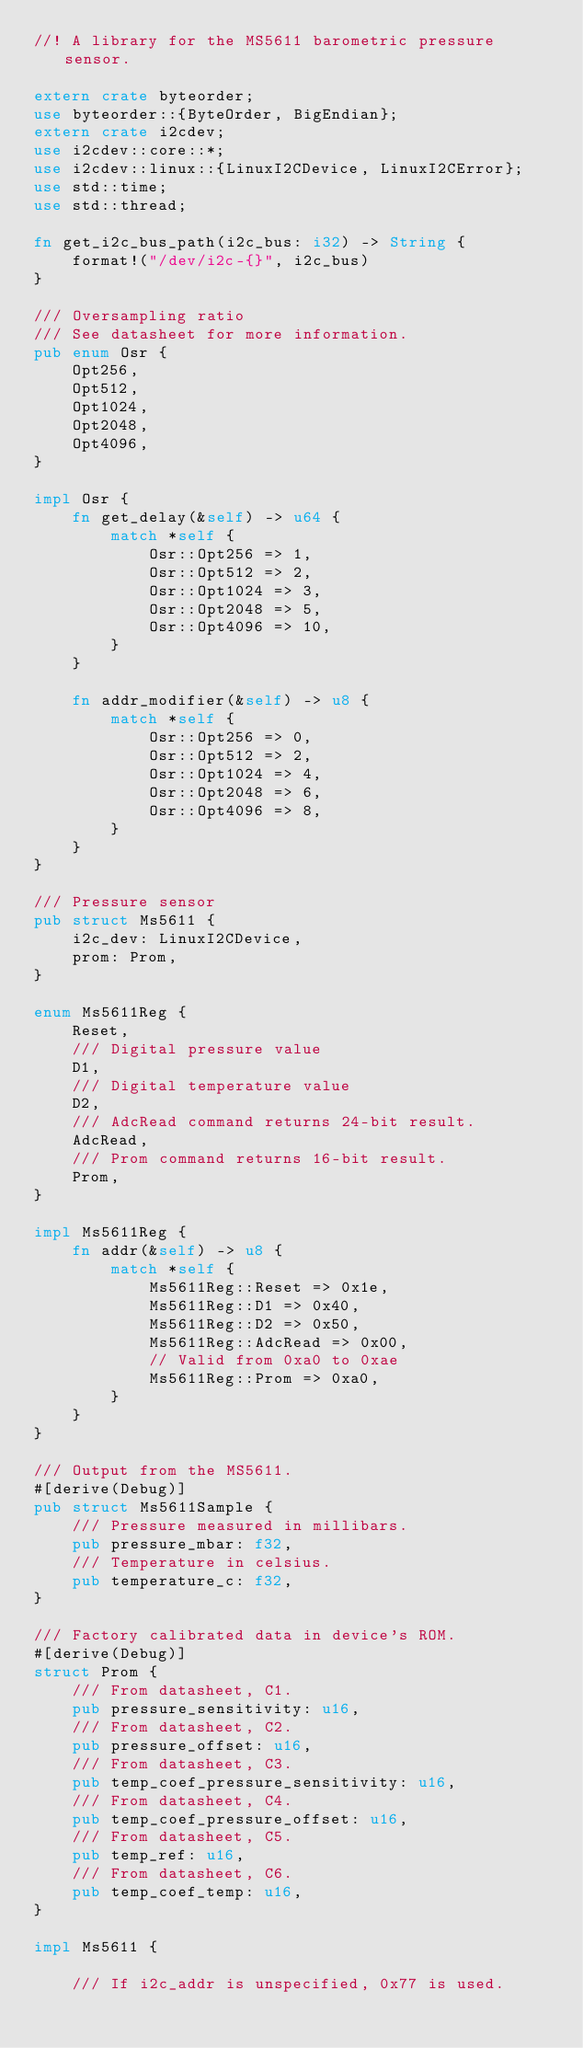<code> <loc_0><loc_0><loc_500><loc_500><_Rust_>//! A library for the MS5611 barometric pressure sensor.

extern crate byteorder;
use byteorder::{ByteOrder, BigEndian};
extern crate i2cdev;
use i2cdev::core::*;
use i2cdev::linux::{LinuxI2CDevice, LinuxI2CError};
use std::time;
use std::thread;

fn get_i2c_bus_path(i2c_bus: i32) -> String {
    format!("/dev/i2c-{}", i2c_bus)
}

/// Oversampling ratio
/// See datasheet for more information.
pub enum Osr {
    Opt256,
    Opt512,
    Opt1024,
    Opt2048,
    Opt4096,
}

impl Osr {
    fn get_delay(&self) -> u64 {
        match *self {
            Osr::Opt256 => 1,
            Osr::Opt512 => 2,
            Osr::Opt1024 => 3,
            Osr::Opt2048 => 5,
            Osr::Opt4096 => 10,
        }
    }

    fn addr_modifier(&self) -> u8 {
        match *self {
            Osr::Opt256 => 0,
            Osr::Opt512 => 2,
            Osr::Opt1024 => 4,
            Osr::Opt2048 => 6,
            Osr::Opt4096 => 8,
        }
    }
}

/// Pressure sensor
pub struct Ms5611 {
    i2c_dev: LinuxI2CDevice,
    prom: Prom,
}

enum Ms5611Reg {
    Reset,
    /// Digital pressure value
    D1,
    /// Digital temperature value
    D2,
    /// AdcRead command returns 24-bit result.
    AdcRead,
    /// Prom command returns 16-bit result.
    Prom,
}

impl Ms5611Reg {
    fn addr(&self) -> u8 {
        match *self {
            Ms5611Reg::Reset => 0x1e,
            Ms5611Reg::D1 => 0x40,
            Ms5611Reg::D2 => 0x50,
            Ms5611Reg::AdcRead => 0x00,
            // Valid from 0xa0 to 0xae
            Ms5611Reg::Prom => 0xa0,
        }
    }
}

/// Output from the MS5611.
#[derive(Debug)]
pub struct Ms5611Sample {
    /// Pressure measured in millibars.
    pub pressure_mbar: f32,
    /// Temperature in celsius.
    pub temperature_c: f32,
}

/// Factory calibrated data in device's ROM.
#[derive(Debug)]
struct Prom {
    /// From datasheet, C1.
    pub pressure_sensitivity: u16,
    /// From datasheet, C2.
    pub pressure_offset: u16,
    /// From datasheet, C3.
    pub temp_coef_pressure_sensitivity: u16,
    /// From datasheet, C4.
    pub temp_coef_pressure_offset: u16,
    /// From datasheet, C5.
    pub temp_ref: u16,
    /// From datasheet, C6.
    pub temp_coef_temp: u16,
}

impl Ms5611 {

    /// If i2c_addr is unspecified, 0x77 is used.</code> 